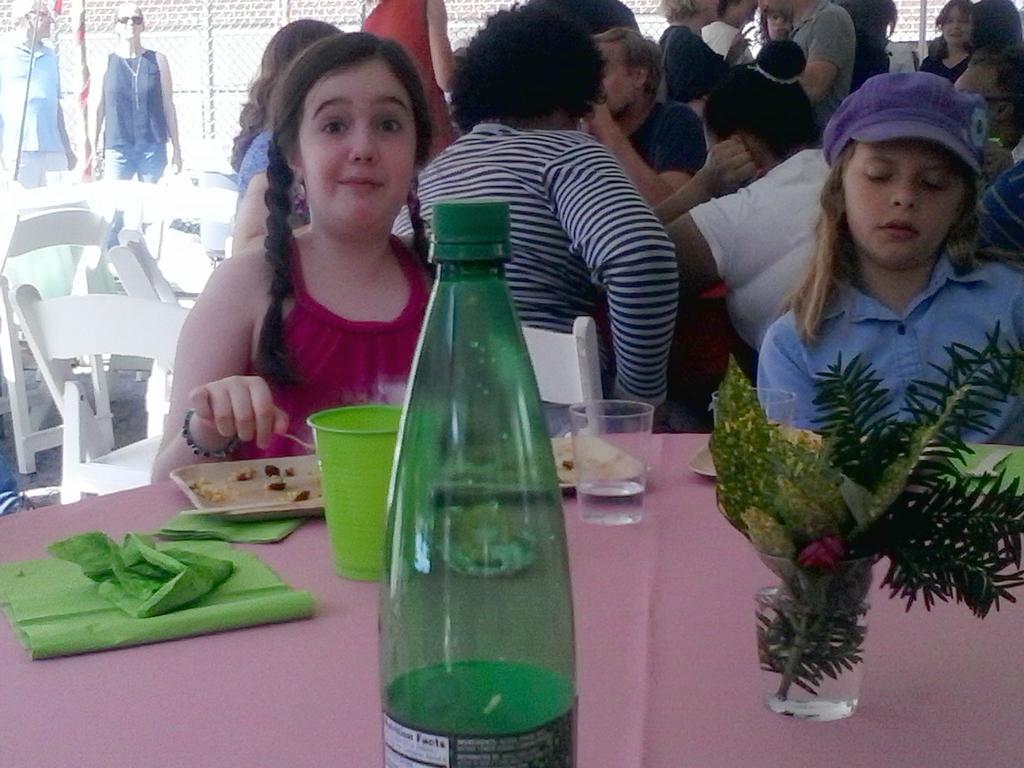How would you summarize this image in a sentence or two? In this image I can see few persons are sitting on the chairs. On the bottom of the image there is a table on which a bottle, glasses, plate and the plant are placed. On the left top of the image there are two persons standing. 